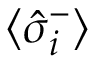<formula> <loc_0><loc_0><loc_500><loc_500>\langle \hat { \sigma } _ { i } ^ { - } \rangle</formula> 